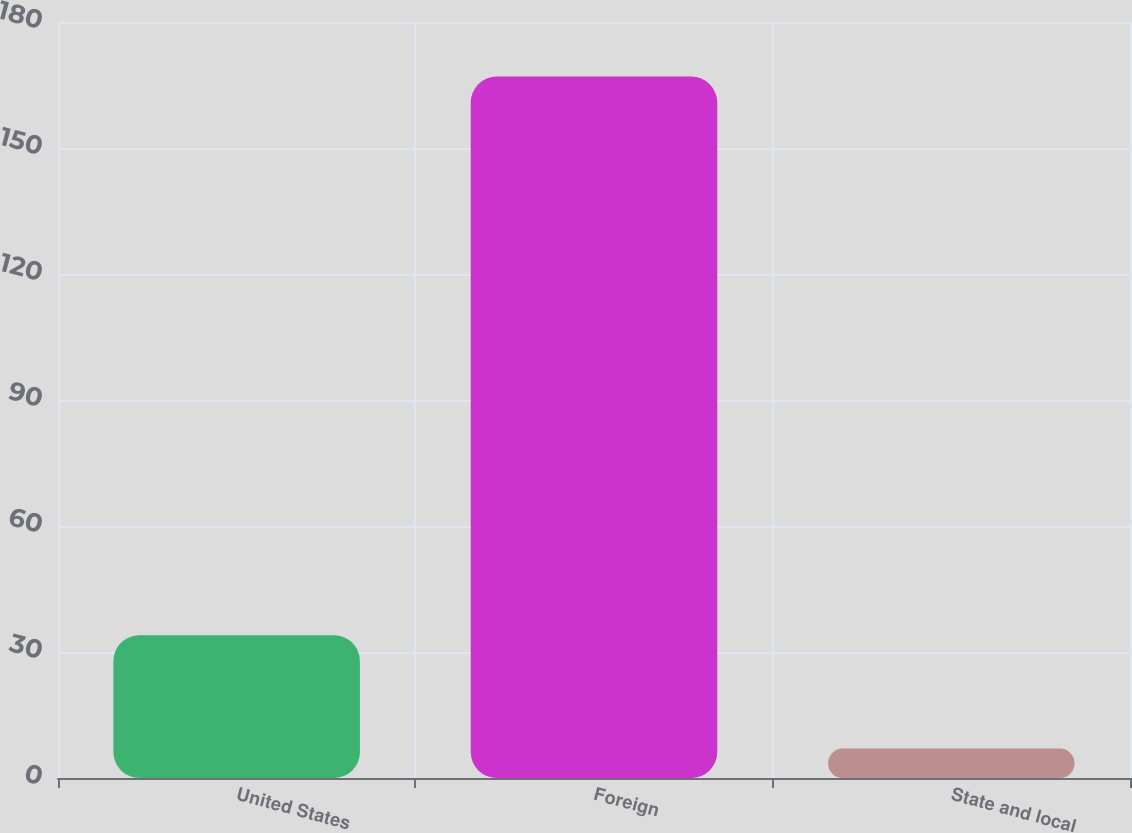Convert chart. <chart><loc_0><loc_0><loc_500><loc_500><bar_chart><fcel>United States<fcel>Foreign<fcel>State and local<nl><fcel>34<fcel>167<fcel>7<nl></chart> 